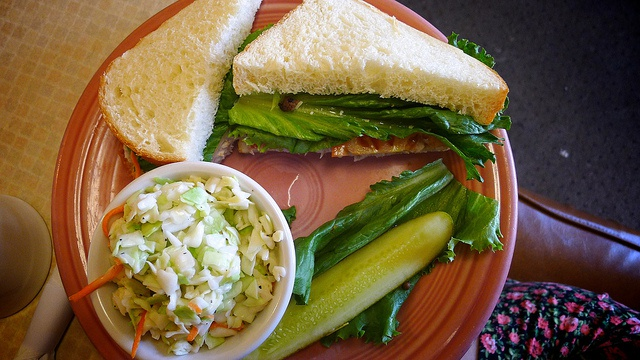Describe the objects in this image and their specific colors. I can see sandwich in maroon, lightgray, tan, black, and olive tones, bowl in maroon, lightgray, tan, and olive tones, couch in maroon, black, and purple tones, cup in maroon, black, and olive tones, and carrot in maroon, brown, and red tones in this image. 